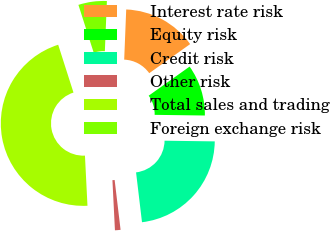Convert chart. <chart><loc_0><loc_0><loc_500><loc_500><pie_chart><fcel>Interest rate risk<fcel>Equity risk<fcel>Credit risk<fcel>Other risk<fcel>Total sales and trading<fcel>Foreign exchange risk<nl><fcel>14.52%<fcel>10.05%<fcel>22.9%<fcel>1.09%<fcel>45.87%<fcel>5.57%<nl></chart> 